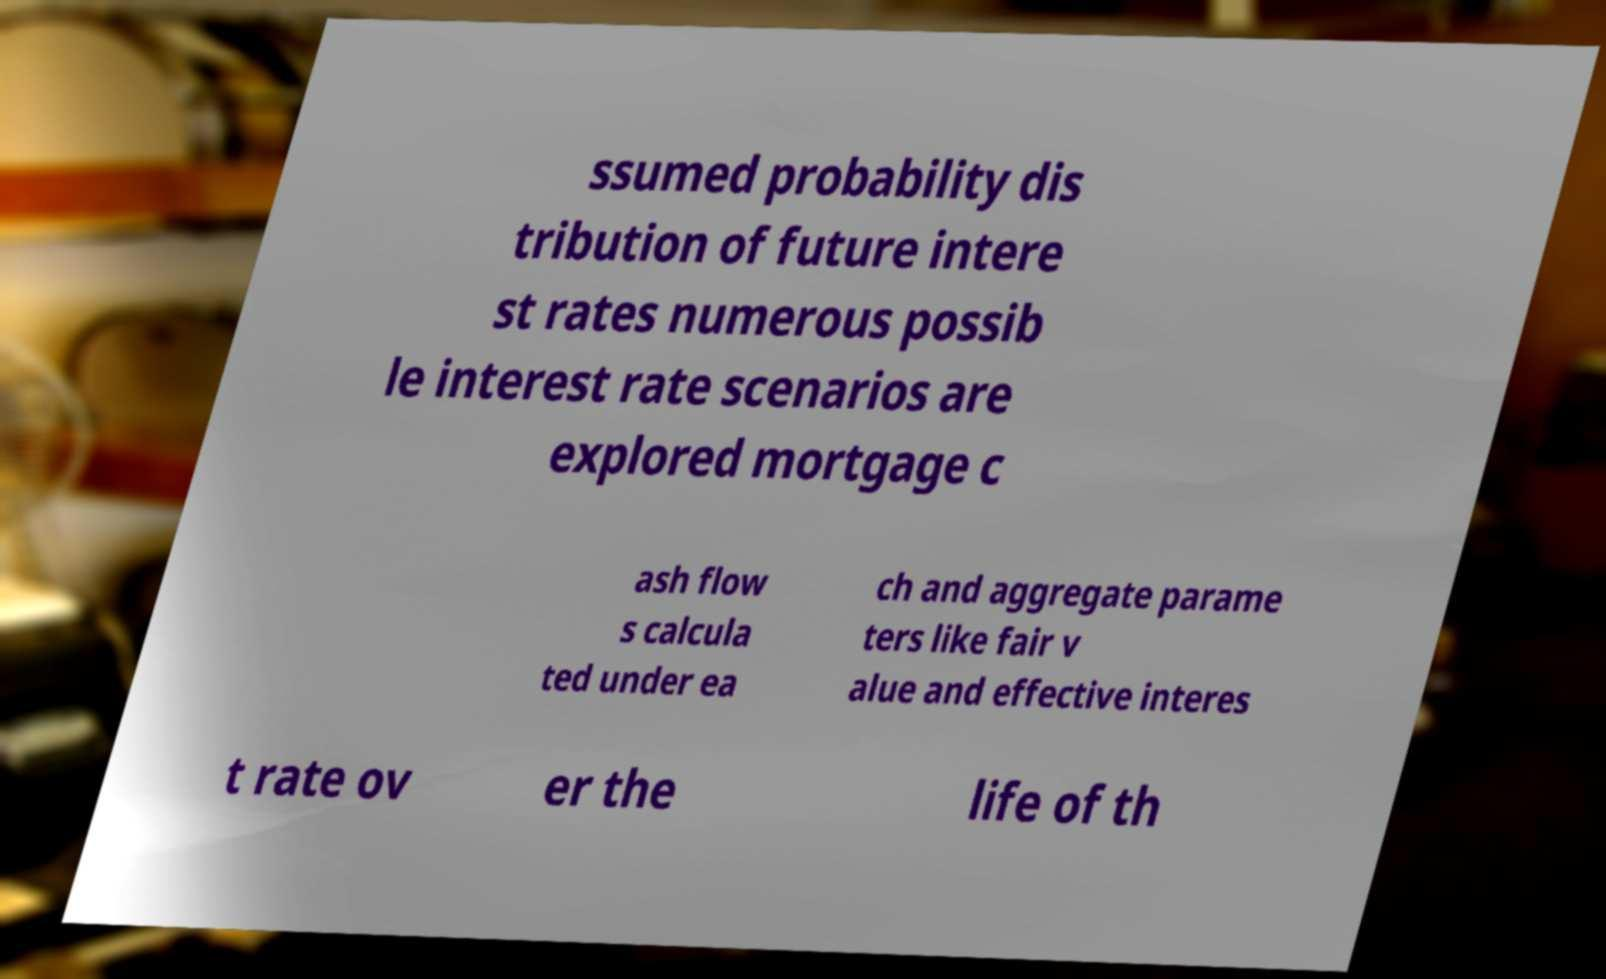Could you assist in decoding the text presented in this image and type it out clearly? ssumed probability dis tribution of future intere st rates numerous possib le interest rate scenarios are explored mortgage c ash flow s calcula ted under ea ch and aggregate parame ters like fair v alue and effective interes t rate ov er the life of th 